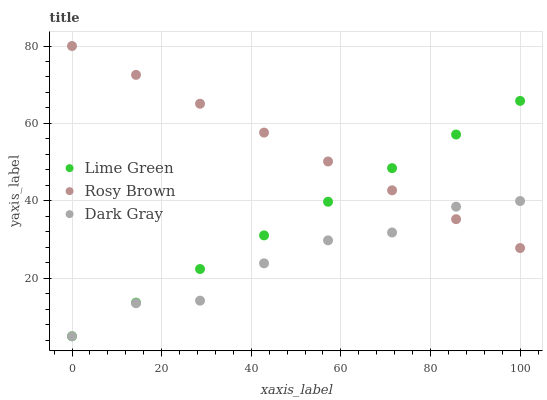Does Dark Gray have the minimum area under the curve?
Answer yes or no. Yes. Does Rosy Brown have the maximum area under the curve?
Answer yes or no. Yes. Does Lime Green have the minimum area under the curve?
Answer yes or no. No. Does Lime Green have the maximum area under the curve?
Answer yes or no. No. Is Lime Green the smoothest?
Answer yes or no. Yes. Is Dark Gray the roughest?
Answer yes or no. Yes. Is Rosy Brown the smoothest?
Answer yes or no. No. Is Rosy Brown the roughest?
Answer yes or no. No. Does Dark Gray have the lowest value?
Answer yes or no. Yes. Does Rosy Brown have the lowest value?
Answer yes or no. No. Does Rosy Brown have the highest value?
Answer yes or no. Yes. Does Lime Green have the highest value?
Answer yes or no. No. Does Dark Gray intersect Lime Green?
Answer yes or no. Yes. Is Dark Gray less than Lime Green?
Answer yes or no. No. Is Dark Gray greater than Lime Green?
Answer yes or no. No. 